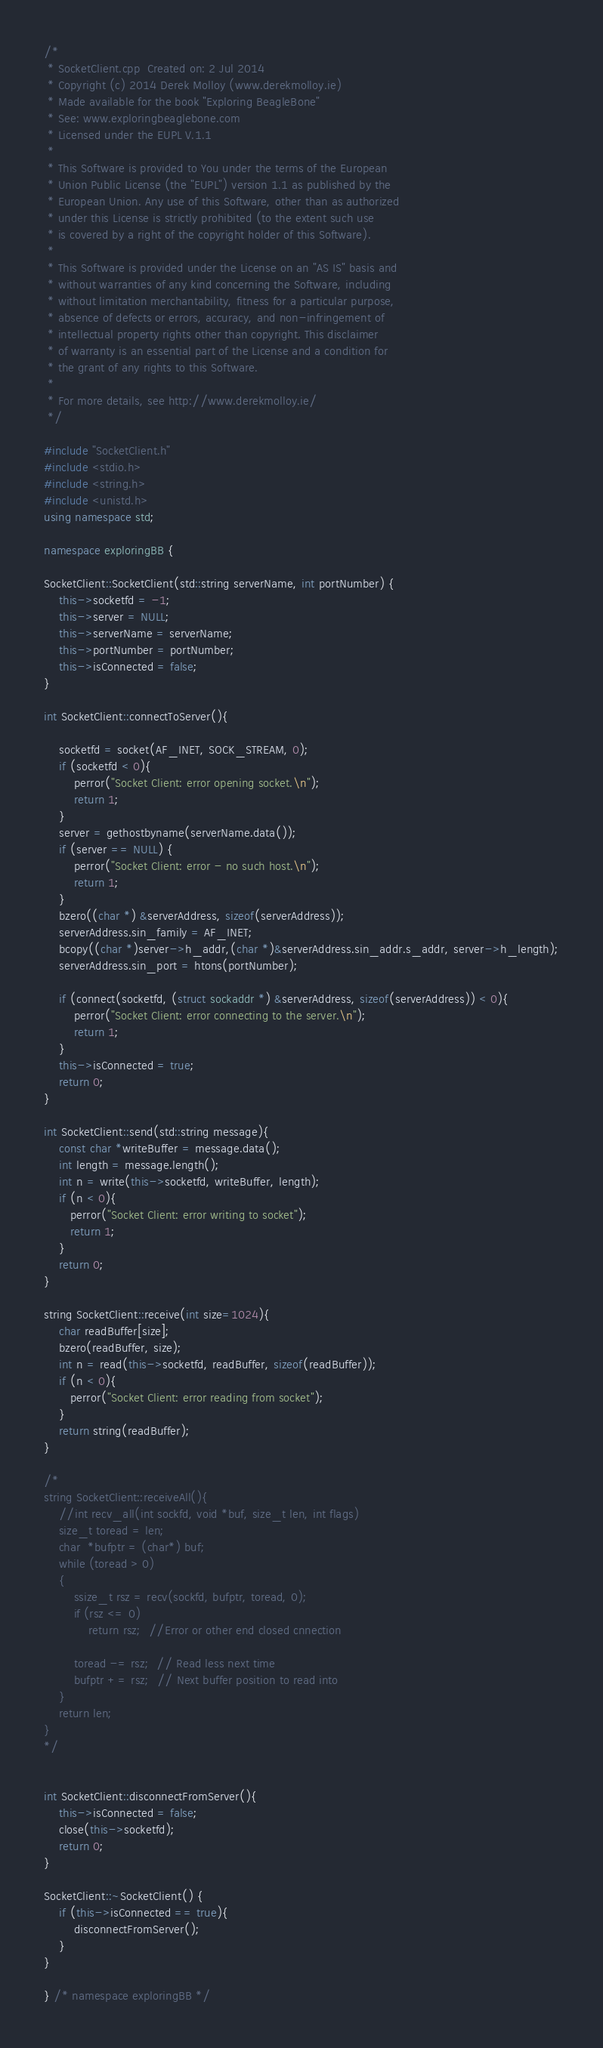<code> <loc_0><loc_0><loc_500><loc_500><_C++_>/*
 * SocketClient.cpp  Created on: 2 Jul 2014
 * Copyright (c) 2014 Derek Molloy (www.derekmolloy.ie)
 * Made available for the book "Exploring BeagleBone" 
 * See: www.exploringbeaglebone.com
 * Licensed under the EUPL V.1.1
 *
 * This Software is provided to You under the terms of the European 
 * Union Public License (the "EUPL") version 1.1 as published by the 
 * European Union. Any use of this Software, other than as authorized 
 * under this License is strictly prohibited (to the extent such use 
 * is covered by a right of the copyright holder of this Software).
 * 
 * This Software is provided under the License on an "AS IS" basis and 
 * without warranties of any kind concerning the Software, including 
 * without limitation merchantability, fitness for a particular purpose, 
 * absence of defects or errors, accuracy, and non-infringement of 
 * intellectual property rights other than copyright. This disclaimer 
 * of warranty is an essential part of the License and a condition for 
 * the grant of any rights to this Software.
 * 
 * For more details, see http://www.derekmolloy.ie/
 */

#include "SocketClient.h"
#include <stdio.h>
#include <string.h>
#include <unistd.h>
using namespace std;

namespace exploringBB {

SocketClient::SocketClient(std::string serverName, int portNumber) {
	this->socketfd = -1;
	this->server = NULL;
	this->serverName = serverName;
	this->portNumber = portNumber;
	this->isConnected = false;
}

int SocketClient::connectToServer(){

    socketfd = socket(AF_INET, SOCK_STREAM, 0);
    if (socketfd < 0){
    	perror("Socket Client: error opening socket.\n");
    	return 1;
    }
    server = gethostbyname(serverName.data());
    if (server == NULL) {
        perror("Socket Client: error - no such host.\n");
        return 1;
    }
    bzero((char *) &serverAddress, sizeof(serverAddress));
    serverAddress.sin_family = AF_INET;
    bcopy((char *)server->h_addr,(char *)&serverAddress.sin_addr.s_addr, server->h_length);
    serverAddress.sin_port = htons(portNumber);

    if (connect(socketfd, (struct sockaddr *) &serverAddress, sizeof(serverAddress)) < 0){
    	perror("Socket Client: error connecting to the server.\n");
    	return 1;
    }
    this->isConnected = true;
    return 0;
}

int SocketClient::send(std::string message){
	const char *writeBuffer = message.data();
	int length = message.length();
    int n = write(this->socketfd, writeBuffer, length);
    if (n < 0){
       perror("Socket Client: error writing to socket");
       return 1;
    }
    return 0;
}

string SocketClient::receive(int size=1024){
    char readBuffer[size];
    bzero(readBuffer, size);
    int n = read(this->socketfd, readBuffer, sizeof(readBuffer));
    if (n < 0){
       perror("Socket Client: error reading from socket");
    }
    return string(readBuffer);
}

/*
string SocketClient::receiveAll(){
	//int recv_all(int sockfd, void *buf, size_t len, int flags)
    size_t toread = len;
    char  *bufptr = (char*) buf;
    while (toread > 0)
    {
        ssize_t rsz = recv(sockfd, bufptr, toread, 0);
        if (rsz <= 0)
            return rsz;  //Error or other end closed cnnection

        toread -= rsz;  // Read less next time
        bufptr += rsz;  // Next buffer position to read into
    }
    return len;
}
*/


int SocketClient::disconnectFromServer(){
	this->isConnected = false;
	close(this->socketfd);
	return 0;
}

SocketClient::~SocketClient() {
	if (this->isConnected == true){
		disconnectFromServer();
	}
}

} /* namespace exploringBB */
</code> 